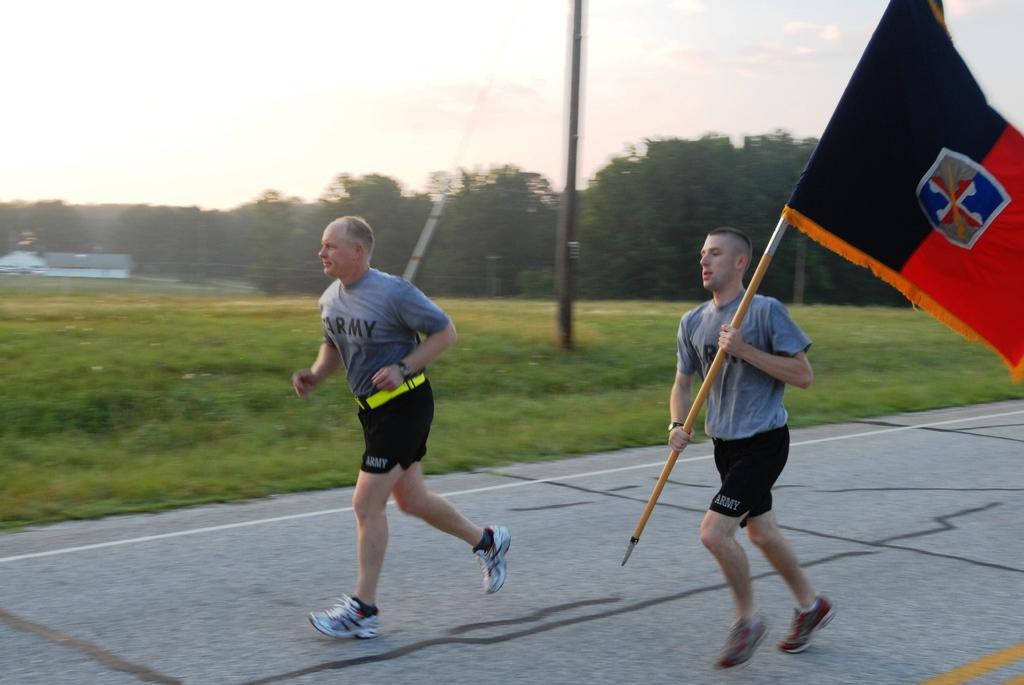Can you describe this image briefly? As we can see in the image there is grass, buildings, two persons wearing grey color t shirts and running. In the background there are trees. At the top there is sky. The man on the right side is holding flag. 